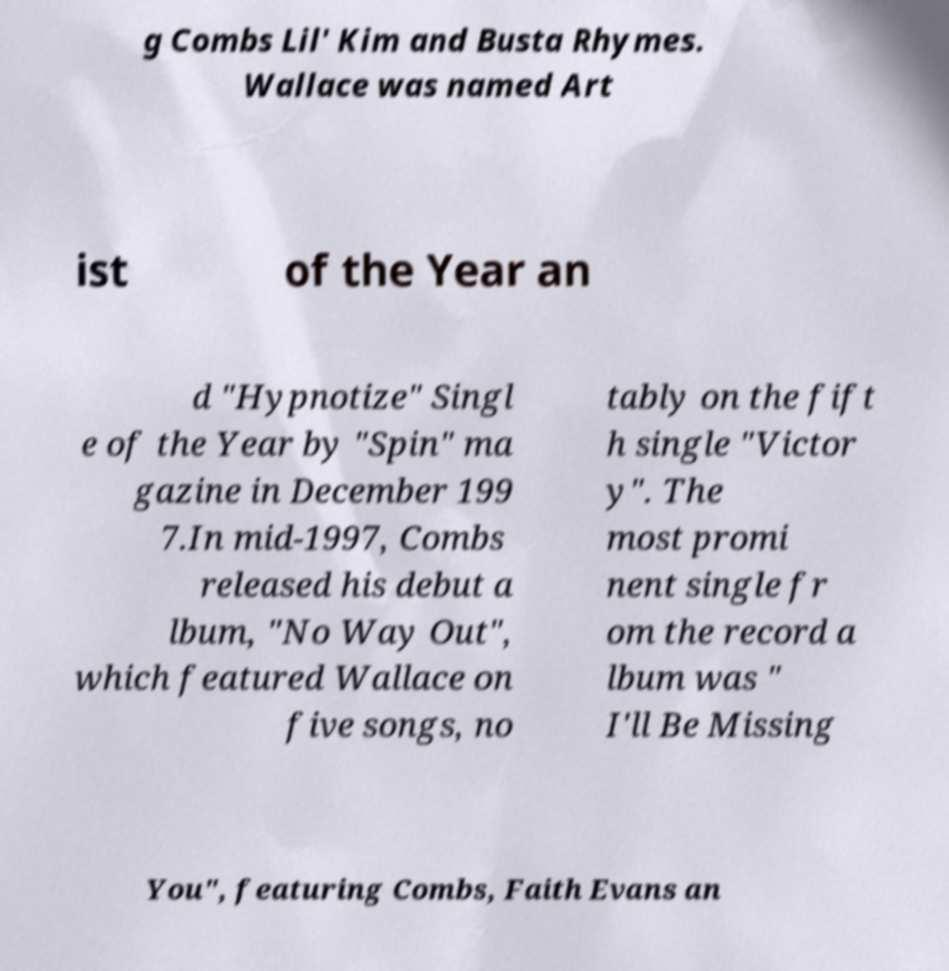I need the written content from this picture converted into text. Can you do that? g Combs Lil' Kim and Busta Rhymes. Wallace was named Art ist of the Year an d "Hypnotize" Singl e of the Year by "Spin" ma gazine in December 199 7.In mid-1997, Combs released his debut a lbum, "No Way Out", which featured Wallace on five songs, no tably on the fift h single "Victor y". The most promi nent single fr om the record a lbum was " I'll Be Missing You", featuring Combs, Faith Evans an 